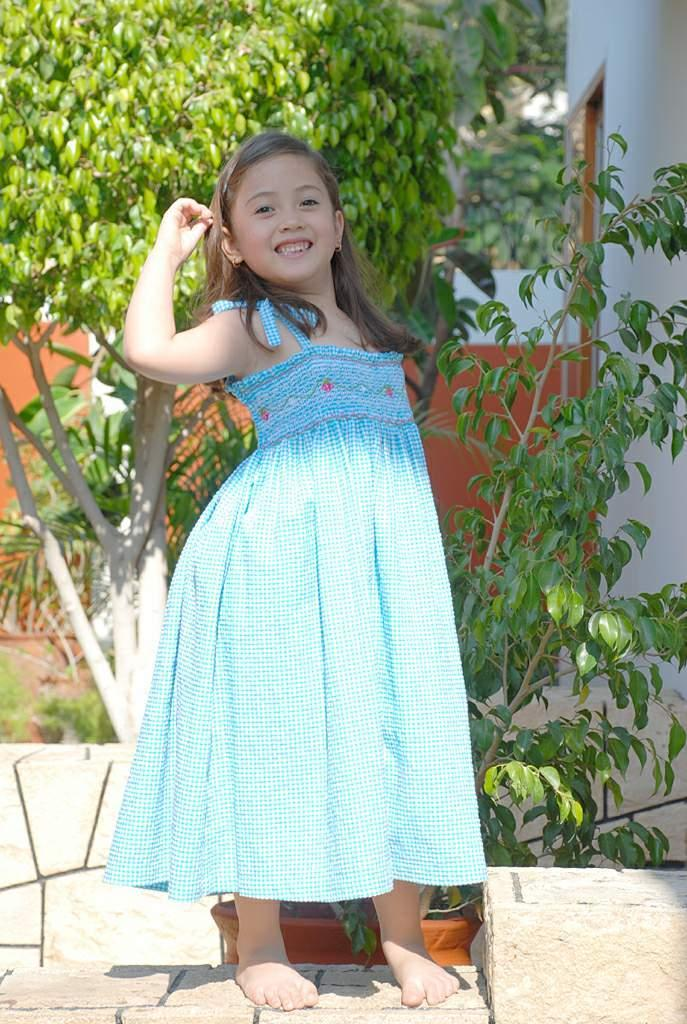Who is the main subject in the image? There is a girl in the image. What is the girl's position in the image? The girl is standing on a pavement. What can be seen in the background of the image? There are plants in the background of the image. What is the friction between the girl and the pavement in the image? The provided facts do not mention any information about the friction between the girl and the pavement, so it cannot be determined from the image. 